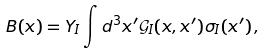<formula> <loc_0><loc_0><loc_500><loc_500>B ( x ) = Y _ { I } \int d ^ { 3 } x ^ { \prime } \mathcal { G } _ { I } ( x , x ^ { \prime } ) \sigma _ { I } ( x ^ { \prime } ) \, ,</formula> 